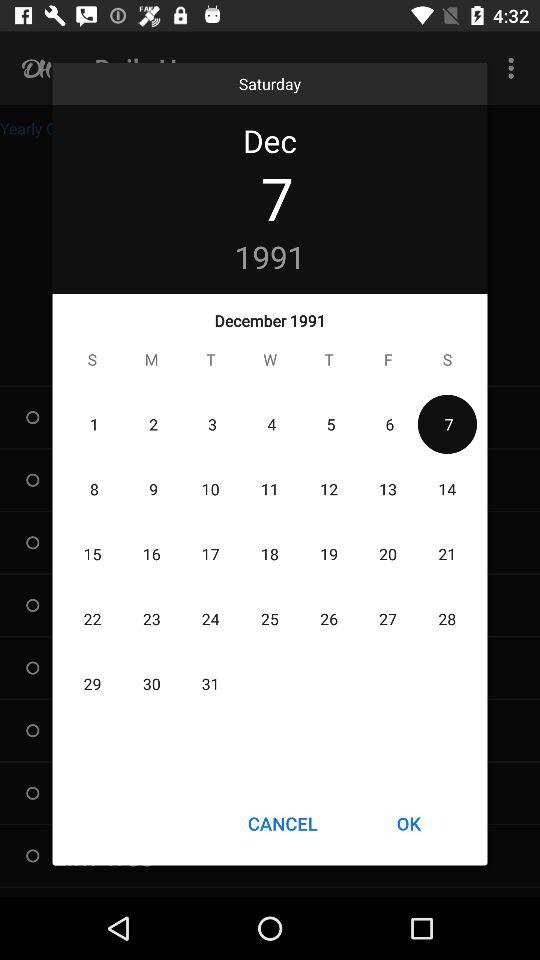What date is selected? The selected date is Saturday, December 7, 1991. 